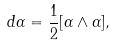Convert formula to latex. <formula><loc_0><loc_0><loc_500><loc_500>d \alpha = { \frac { 1 } { 2 } } [ \alpha \wedge \alpha ] ,</formula> 